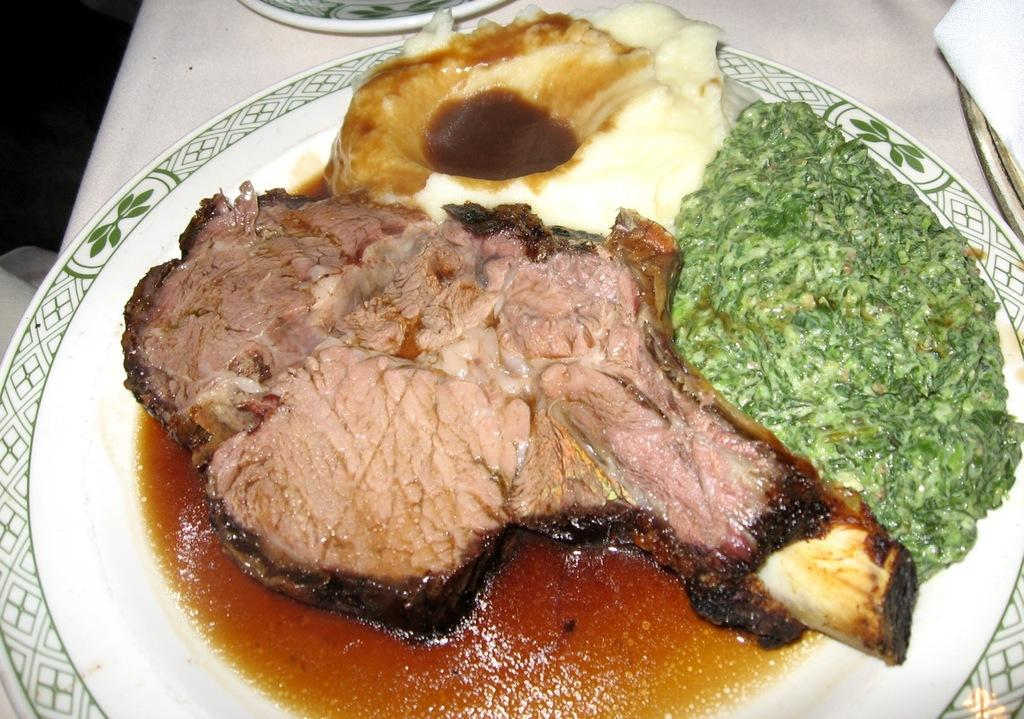What is the main object in the center of the image? There is a plate in the center of the image. What is on the plate? The plate contains food items. Can you identify any specific type of food in the image? Yes, beef is present in the food items on the plate. What type of question is being asked by the band during the holiday in the image? There is no band or holiday present in the image, so it is not possible to answer that question. 